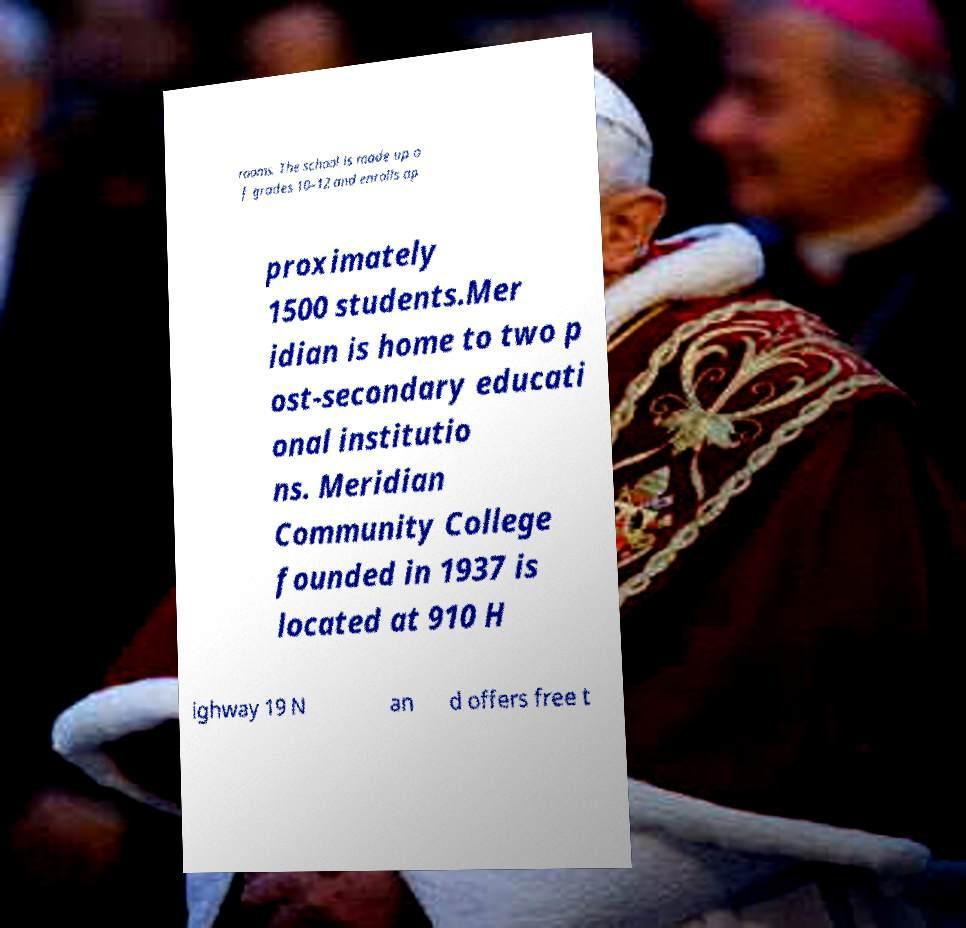I need the written content from this picture converted into text. Can you do that? rooms. The school is made up o f grades 10–12 and enrolls ap proximately 1500 students.Mer idian is home to two p ost-secondary educati onal institutio ns. Meridian Community College founded in 1937 is located at 910 H ighway 19 N an d offers free t 